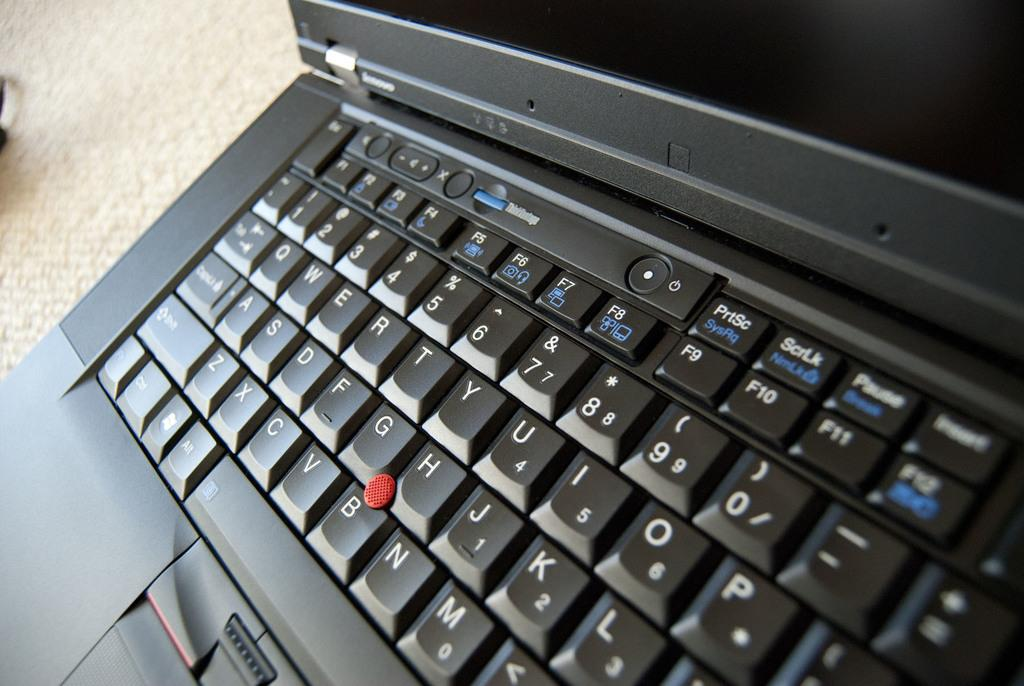<image>
Render a clear and concise summary of the photo. A black keyboard has a button that says PrtSc near the top. 